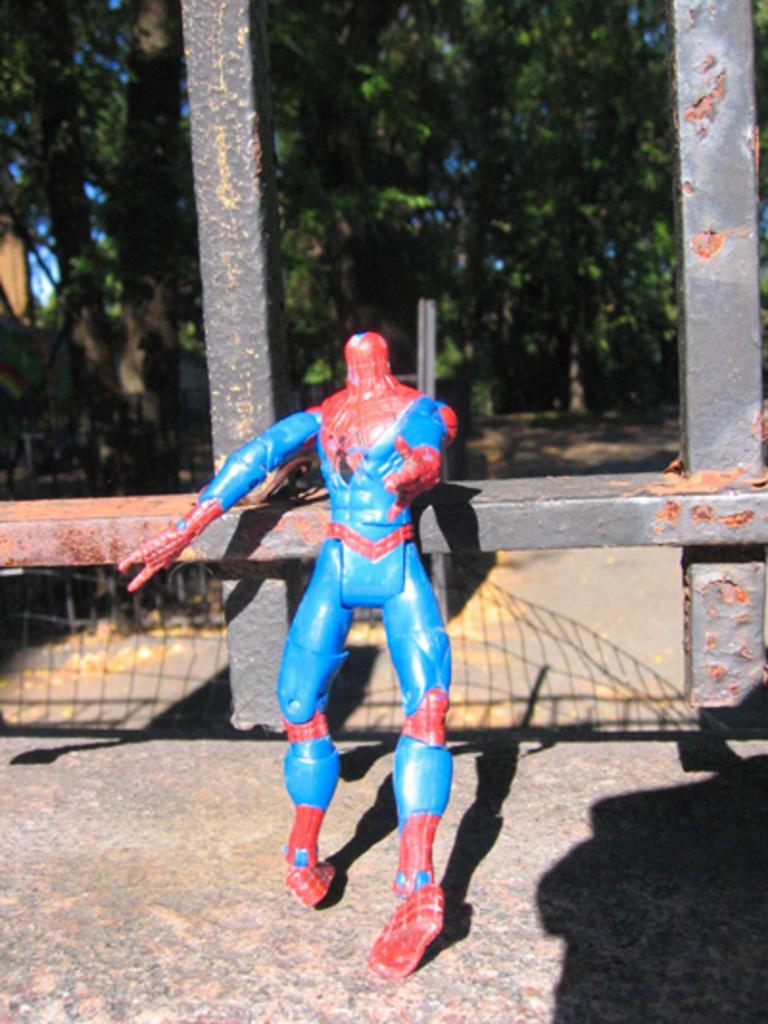Please provide a concise description of this image. In this image there is a toy standing on the road. Behind it there are metal rods. In the background there are trees. 